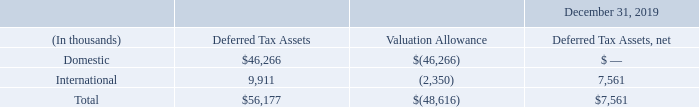The Company continually reviews the adequacy of our valuation allowance and recognizes the benefits of deferred tax assets only as the reassessment indicates that it is more likely than not that the deferred tax assets will be realized in accordance with ASC 740, Income Taxes. Due to our recent decrease in revenue and profitability for 2019, and all other positive and negative objective evidence considered as part of our analysis, our ability to consider other subjective evidence such as projections for future growth is limited when evaluating whether our deferred tax assets will be realized. As such, the Company was no longer able to conclude that it was more likely than not that our domestic deferred tax assets would be realized and a valuation allowance against our domestic deferred tax assets was established in the third quarter of 2019. The amount of the deferred tax assets considered realizable may be adjusted in future periods in the event that sufficient evidence is present to support a conclusion that it is more likely than not that all or a portion of our domestic deferred tax assets will be realized.
As of December 31, 2019, the Company had gross deferred tax assets totaling $56.2 million offset by a valuation allowance totaling $48.6 million. Of the valuation allowance, $42.8 million was established in the current year primarily related to our domestic deferred tax assets. The remaining $5.8 million established in prior periods related to state research and development credit carryforwards and foreign net operating loss and research and development credit carryforwards where we lack sufficient activity to realize those deferred tax assets. The remaining $7.6 million in deferred tax assets that were not offset by a valuation allowance are located in various foreign jurisdictions where the Company believes it is more likely than not we will realize these deferred tax assets.
Supplemental balance sheet information related to deferred tax assets is as follows:
As of December 31, 2019 and 2018, the deferred tax assets for foreign and domestic loss carry-forwards, research and development tax credits, unamortized research and development costs and state credit carryforwards totaled $41.3 million and $28.8 million, respectively. As of December 31, 2019, $19.1 million of these deferred tax assets will expire at various times between 2020 and 2039. The remaining deferred tax assets will either amortize through 2029 or carryforward indefinitely.
As of December 31, 2019 and 2018, respectively, our cash and cash equivalents were $73.8 million and $105.5 million and short-term investments were $33.2 million and $3.2 million, which provided available short-term liquidity of $107.0 million and $108.7 million. Of these amounts, our foreign subsidiaries held cash of $52.3 million and $87.1 million, respectively, representing approximately 48.9% and 80.1% of available short-term liquidity, which is used to fund on-going liquidity needs of these subsidiaries. We intend to permanently reinvest these funds outside the U.S. except to the extent any of these funds can be repatriated without withholding tax and our current business plans do not indicate a need to repatriate to fund domestic operations. However, if all of these funds were repatriated to the U.S. or used for U.S. operations, certain amounts could be subject to tax. Due to the timing and circumstances of repatriation of such earnings, if any, it is not practical to determine the amount of funds subject to unrecognized deferred tax liability.
During 2019, 2018 and 2017, no income tax benefit or expense was recorded for stock options exercised as an adjustment to equity.
What does the table show? Supplemental balance sheet information related to deferred tax assets. What was the company's International deferred tax assets?
Answer scale should be: thousand. 9,911. What was the company's domestic deferred tax assets?
Answer scale should be: thousand. $46,266. What was the difference between domestic and international deferred tax assets?
Answer scale should be: thousand. $46,266-9,911
Answer: 36355. What is the total Deferred Tax Assets, net expressed as a ratio to total Deferred Tax Assets? 7,561/56,177
Answer: 0.13. What was domestic deferred tax assets as a percentage of the total deferred tax assets?
Answer scale should be: percent. $46,266/$56,177
Answer: 82.36. 